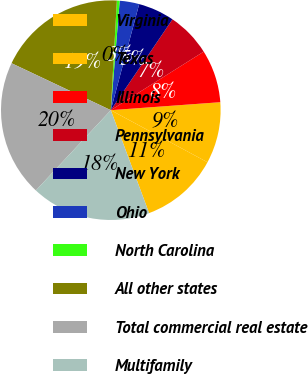Convert chart to OTSL. <chart><loc_0><loc_0><loc_500><loc_500><pie_chart><fcel>Virginia<fcel>Texas<fcel>Illinois<fcel>Pennsylvania<fcel>New York<fcel>Ohio<fcel>North Carolina<fcel>All other states<fcel>Total commercial real estate<fcel>Multifamily<nl><fcel>11.47%<fcel>9.02%<fcel>7.79%<fcel>6.56%<fcel>5.33%<fcel>2.87%<fcel>0.41%<fcel>18.85%<fcel>20.08%<fcel>17.62%<nl></chart> 